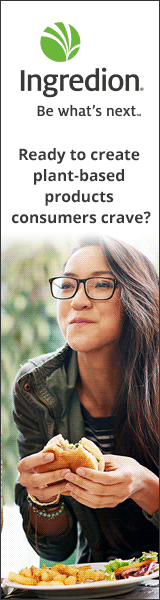what is the woman eating? The woman is eating a plant-based burger with friends. 